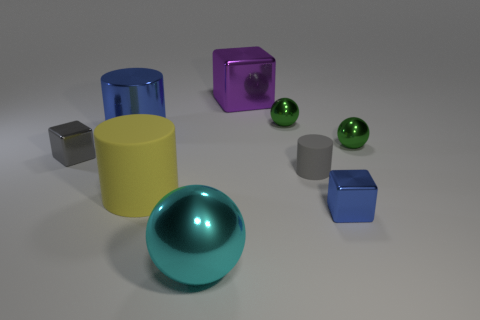Add 1 tiny matte cylinders. How many objects exist? 10 Subtract all spheres. How many objects are left? 6 Add 4 matte cylinders. How many matte cylinders are left? 6 Add 9 red metal balls. How many red metal balls exist? 9 Subtract 1 cyan balls. How many objects are left? 8 Subtract all metallic things. Subtract all small blue matte balls. How many objects are left? 2 